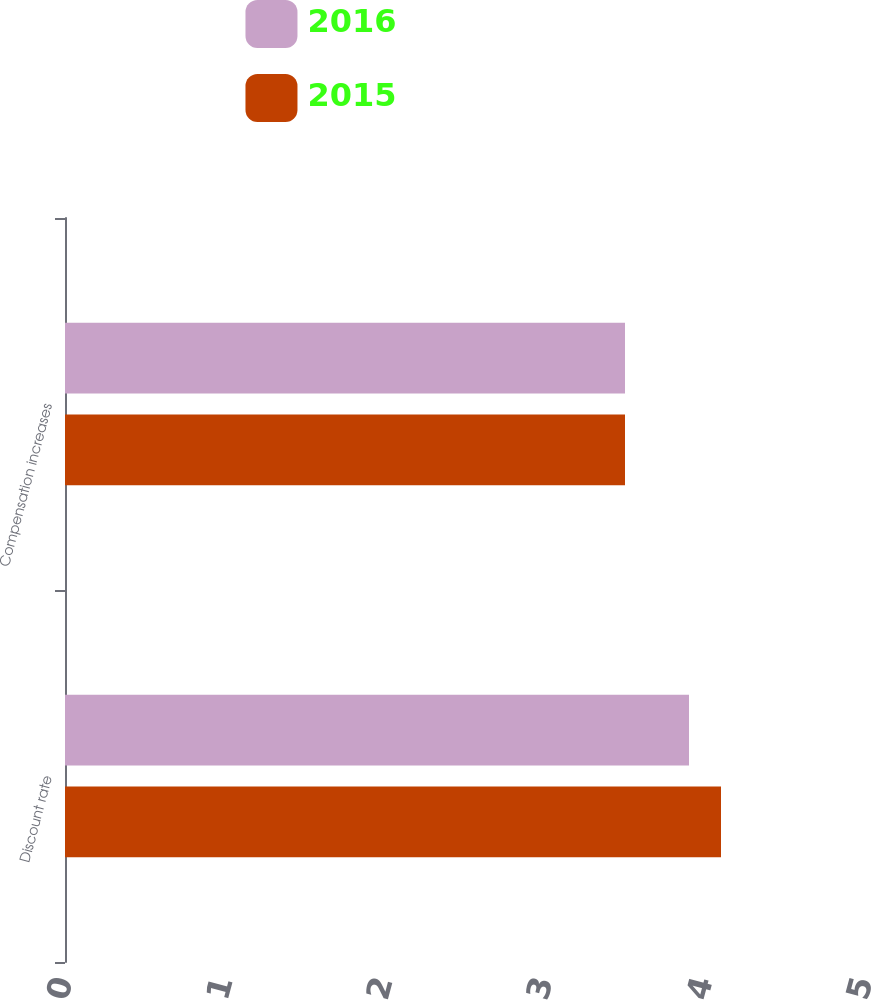Convert chart. <chart><loc_0><loc_0><loc_500><loc_500><stacked_bar_chart><ecel><fcel>Discount rate<fcel>Compensation increases<nl><fcel>2016<fcel>3.9<fcel>3.5<nl><fcel>2015<fcel>4.1<fcel>3.5<nl></chart> 